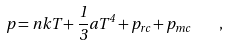Convert formula to latex. <formula><loc_0><loc_0><loc_500><loc_500>p = n k T + \frac { 1 } { 3 } a T ^ { 4 } + p _ { r c } + p _ { m c } \quad ,</formula> 